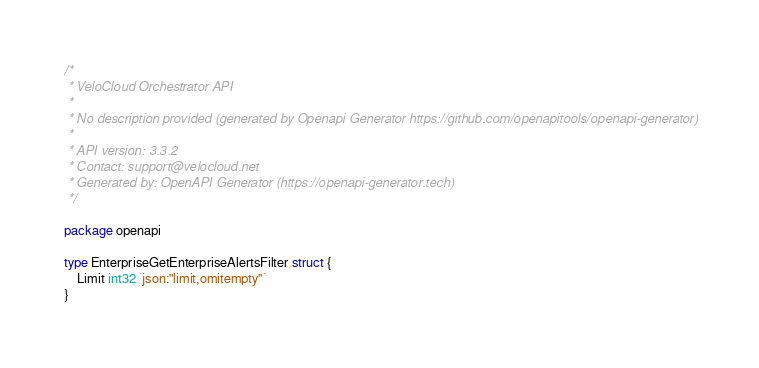Convert code to text. <code><loc_0><loc_0><loc_500><loc_500><_Go_>/*
 * VeloCloud Orchestrator API
 *
 * No description provided (generated by Openapi Generator https://github.com/openapitools/openapi-generator)
 *
 * API version: 3.3.2
 * Contact: support@velocloud.net
 * Generated by: OpenAPI Generator (https://openapi-generator.tech)
 */

package openapi

type EnterpriseGetEnterpriseAlertsFilter struct {
	Limit int32 `json:"limit,omitempty"`
}
</code> 